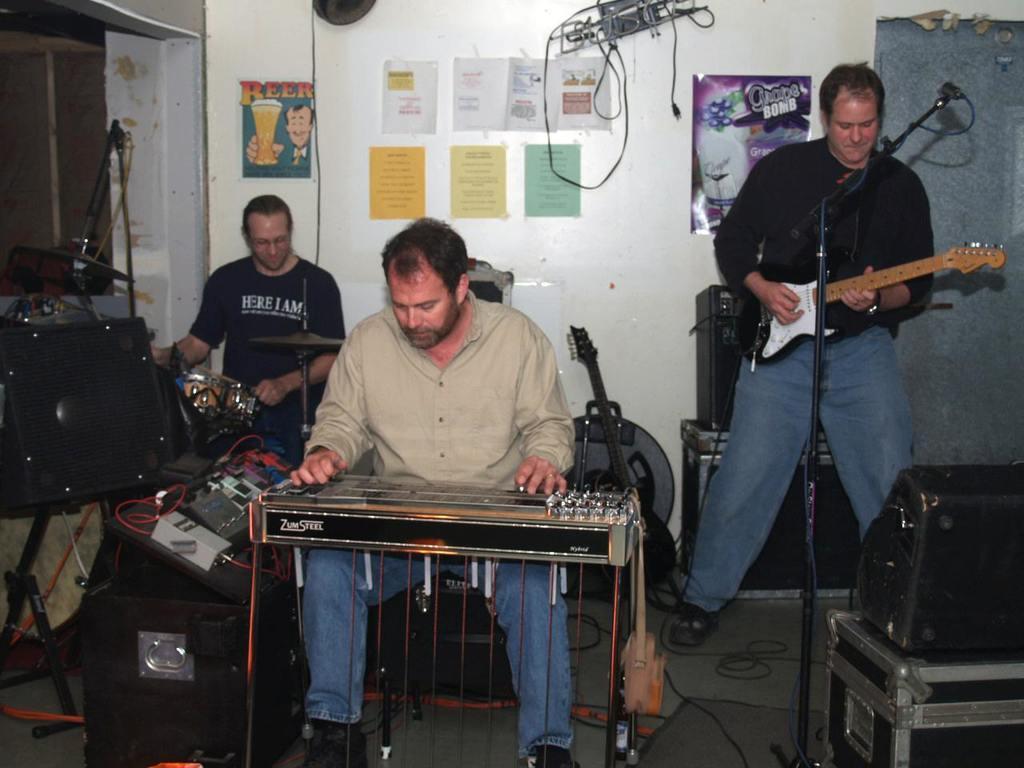In one or two sentences, can you explain what this image depicts? a person is sitting in the center and correcting the base. at the right a person is standing and playing guitar. he is wearing black shirt and a jeans. in front of him there is a microphone. at the left back a person is sitting, wearing a black t shirt and playing drums. behind them there is a white wall on which there are colorful paper notes. in the front there are black box and a black bag. 